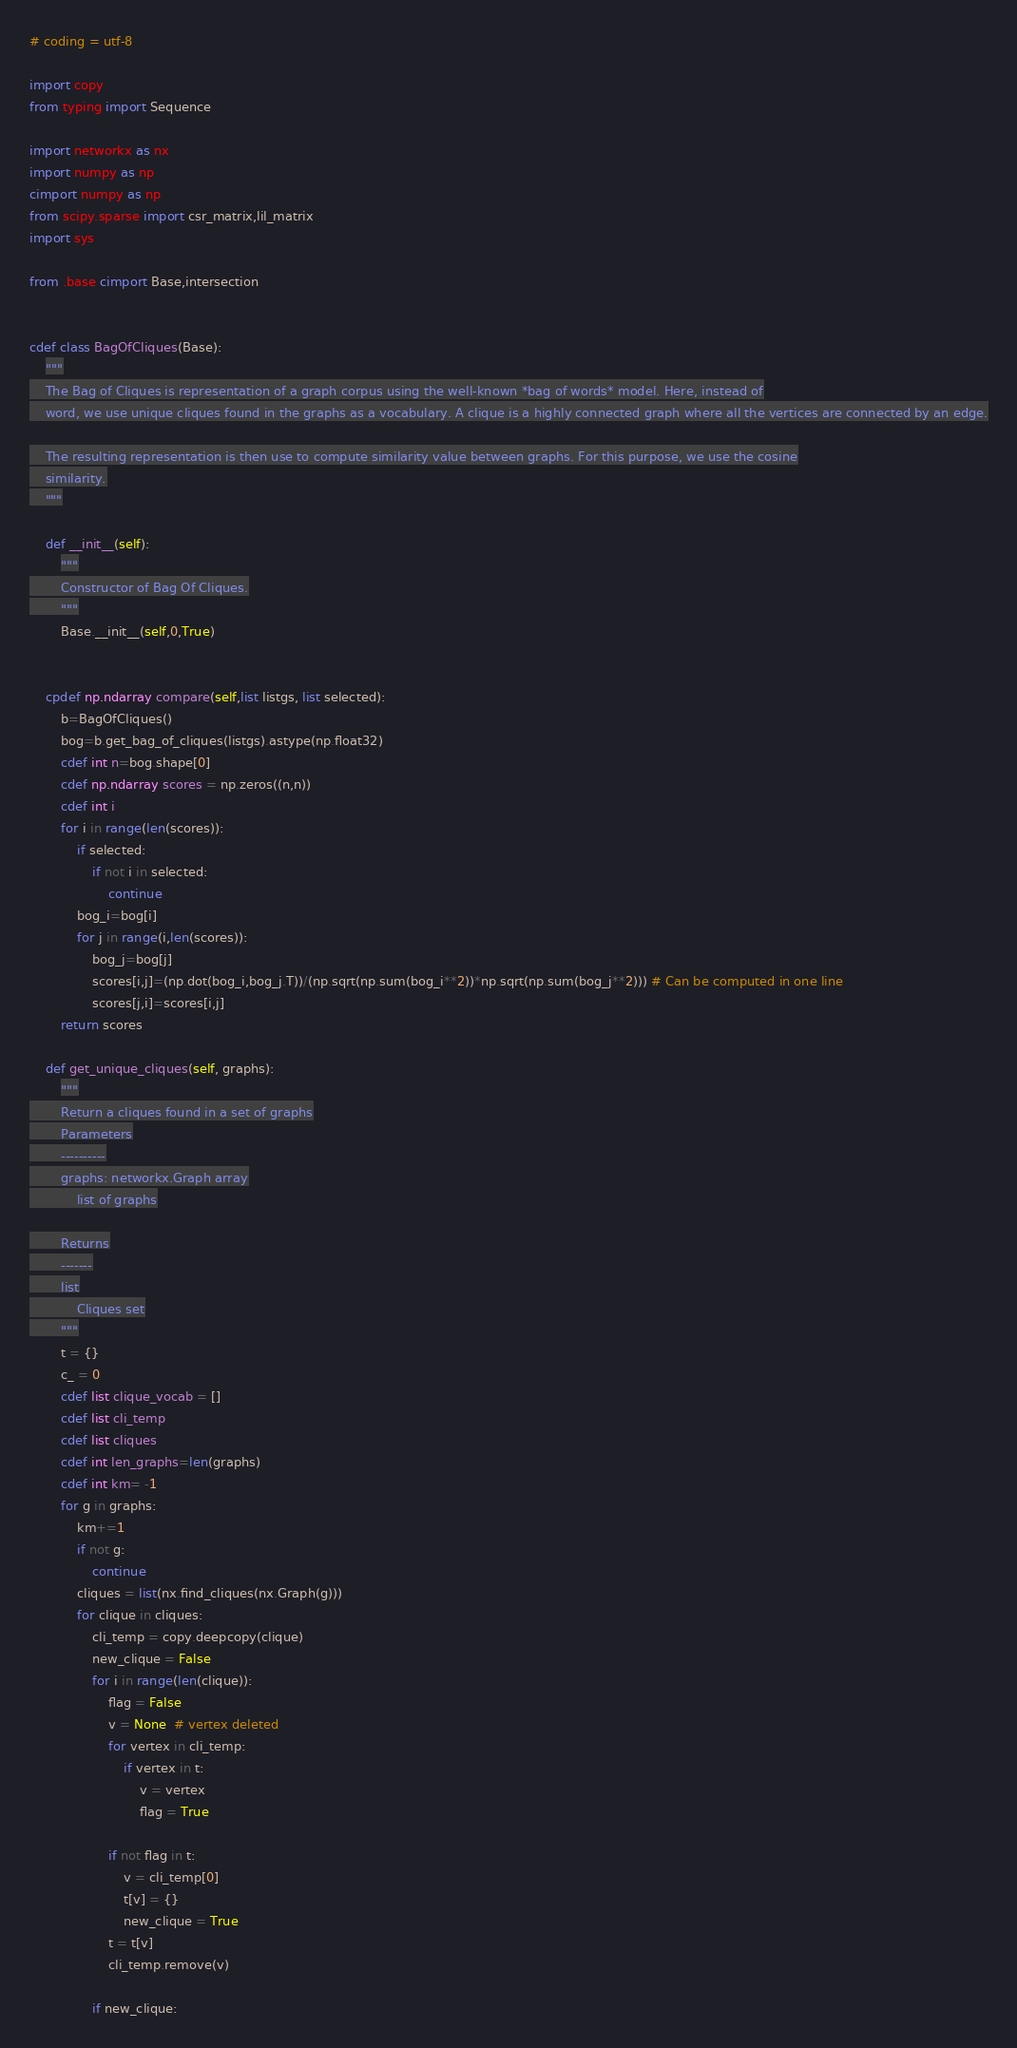<code> <loc_0><loc_0><loc_500><loc_500><_Cython_># coding = utf-8

import copy
from typing import Sequence

import networkx as nx
import numpy as np
cimport numpy as np
from scipy.sparse import csr_matrix,lil_matrix
import sys

from .base cimport Base,intersection


cdef class BagOfCliques(Base):
    """
    The Bag of Cliques is representation of a graph corpus using the well-known *bag of words* model. Here, instead of
    word, we use unique cliques found in the graphs as a vocabulary. A clique is a highly connected graph where all the vertices are connected by an edge.

    The resulting representation is then use to compute similarity value between graphs. For this purpose, we use the cosine
    similarity.
    """

    def __init__(self):
        """
        Constructor of Bag Of Cliques.
        """
        Base.__init__(self,0,True)


    cpdef np.ndarray compare(self,list listgs, list selected):
        b=BagOfCliques()
        bog=b.get_bag_of_cliques(listgs).astype(np.float32)
        cdef int n=bog.shape[0]
        cdef np.ndarray scores = np.zeros((n,n))
        cdef int i
        for i in range(len(scores)):
            if selected:
                if not i in selected:
                    continue
            bog_i=bog[i]
            for j in range(i,len(scores)):
                bog_j=bog[j]
                scores[i,j]=(np.dot(bog_i,bog_j.T))/(np.sqrt(np.sum(bog_i**2))*np.sqrt(np.sum(bog_j**2))) # Can be computed in one line
                scores[j,i]=scores[i,j]
        return scores

    def get_unique_cliques(self, graphs):
        """
        Return a cliques found in a set of graphs
        Parameters
        ----------
        graphs: networkx.Graph array
            list of graphs

        Returns
        -------
        list
            Cliques set
        """
        t = {}
        c_ = 0
        cdef list clique_vocab = []
        cdef list cli_temp
        cdef list cliques
        cdef int len_graphs=len(graphs)
        cdef int km= -1
        for g in graphs:
            km+=1
            if not g:
                continue
            cliques = list(nx.find_cliques(nx.Graph(g)))
            for clique in cliques:
                cli_temp = copy.deepcopy(clique)
                new_clique = False
                for i in range(len(clique)):
                    flag = False
                    v = None  # vertex deleted
                    for vertex in cli_temp:
                        if vertex in t:
                            v = vertex
                            flag = True

                    if not flag in t:
                        v = cli_temp[0]
                        t[v] = {}
                        new_clique = True
                    t = t[v]
                    cli_temp.remove(v)

                if new_clique:</code> 